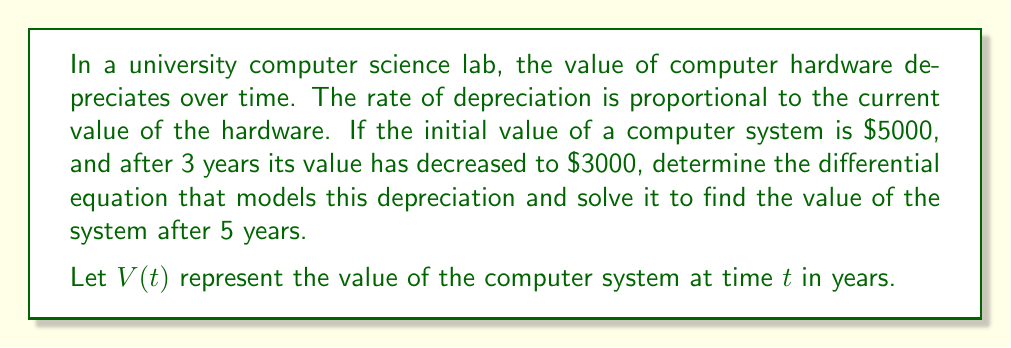What is the answer to this math problem? Let's approach this problem step by step:

1) First, we need to set up the differential equation. The rate of change of value is proportional to the current value:

   $$\frac{dV}{dt} = -kV$$

   where $k$ is the depreciation constant (positive).

2) This is a separable first-order differential equation. We can solve it as follows:

   $$\frac{dV}{V} = -k dt$$

3) Integrating both sides:

   $$\int \frac{dV}{V} = -\int k dt$$
   $$\ln|V| = -kt + C$$

4) Solving for $V$:

   $$V(t) = Ae^{-kt}$$

   where $A$ is a constant.

5) Now, we can use the initial condition. At $t=0$, $V(0) = 5000$:

   $$5000 = Ae^{-k(0)} = A$$

6) So our equation becomes:

   $$V(t) = 5000e^{-kt}$$

7) We can use the second condition to find $k$. After 3 years, the value is $3000:

   $$3000 = 5000e^{-k(3)}$$

8) Solving for $k$:

   $$\frac{3000}{5000} = e^{-3k}$$
   $$\ln(0.6) = -3k$$
   $$k = -\frac{\ln(0.6)}{3} \approx 0.1701$$

9) Now we have our complete equation:

   $$V(t) = 5000e^{-0.1701t}$$

10) To find the value after 5 years, we simply plug in $t=5$:

    $$V(5) = 5000e^{-0.1701(5)} \approx 2231.30$$
Answer: The differential equation modeling the depreciation is:

$$\frac{dV}{dt} = -kV$$

where $k \approx 0.1701$.

The solution to this equation is:

$$V(t) = 5000e^{-0.1701t}$$

After 5 years, the value of the computer system will be approximately $2231.30. 